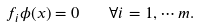<formula> <loc_0><loc_0><loc_500><loc_500>f _ { i } \phi ( x ) = 0 \quad \forall i = 1 , \cdots m .</formula> 